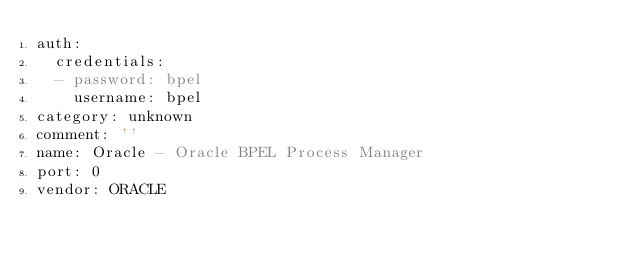Convert code to text. <code><loc_0><loc_0><loc_500><loc_500><_YAML_>auth:
  credentials:
  - password: bpel
    username: bpel
category: unknown
comment: ''
name: Oracle - Oracle BPEL Process Manager
port: 0
vendor: ORACLE
</code> 